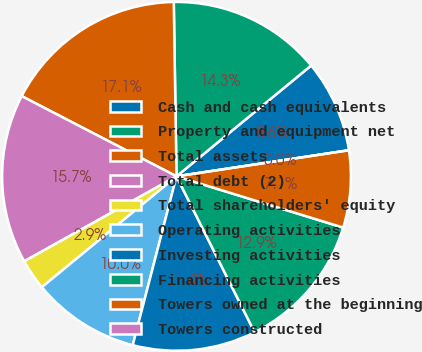Convert chart. <chart><loc_0><loc_0><loc_500><loc_500><pie_chart><fcel>Cash and cash equivalents<fcel>Property and equipment net<fcel>Total assets<fcel>Total debt (2)<fcel>Total shareholders' equity<fcel>Operating activities<fcel>Investing activities<fcel>Financing activities<fcel>Towers owned at the beginning<fcel>Towers constructed<nl><fcel>8.57%<fcel>14.29%<fcel>17.14%<fcel>15.71%<fcel>2.86%<fcel>10.0%<fcel>11.43%<fcel>12.86%<fcel>7.14%<fcel>0.0%<nl></chart> 